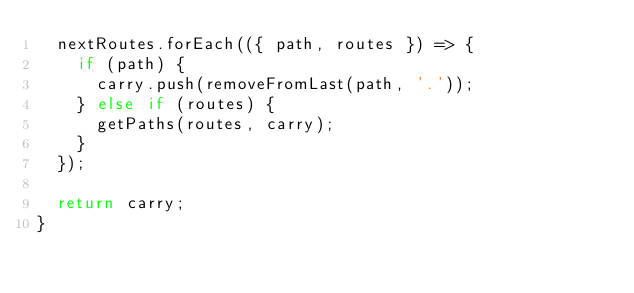Convert code to text. <code><loc_0><loc_0><loc_500><loc_500><_JavaScript_>  nextRoutes.forEach(({ path, routes }) => {
    if (path) {
      carry.push(removeFromLast(path, '.'));
    } else if (routes) {
      getPaths(routes, carry);
    }
  });

  return carry;
}
</code> 